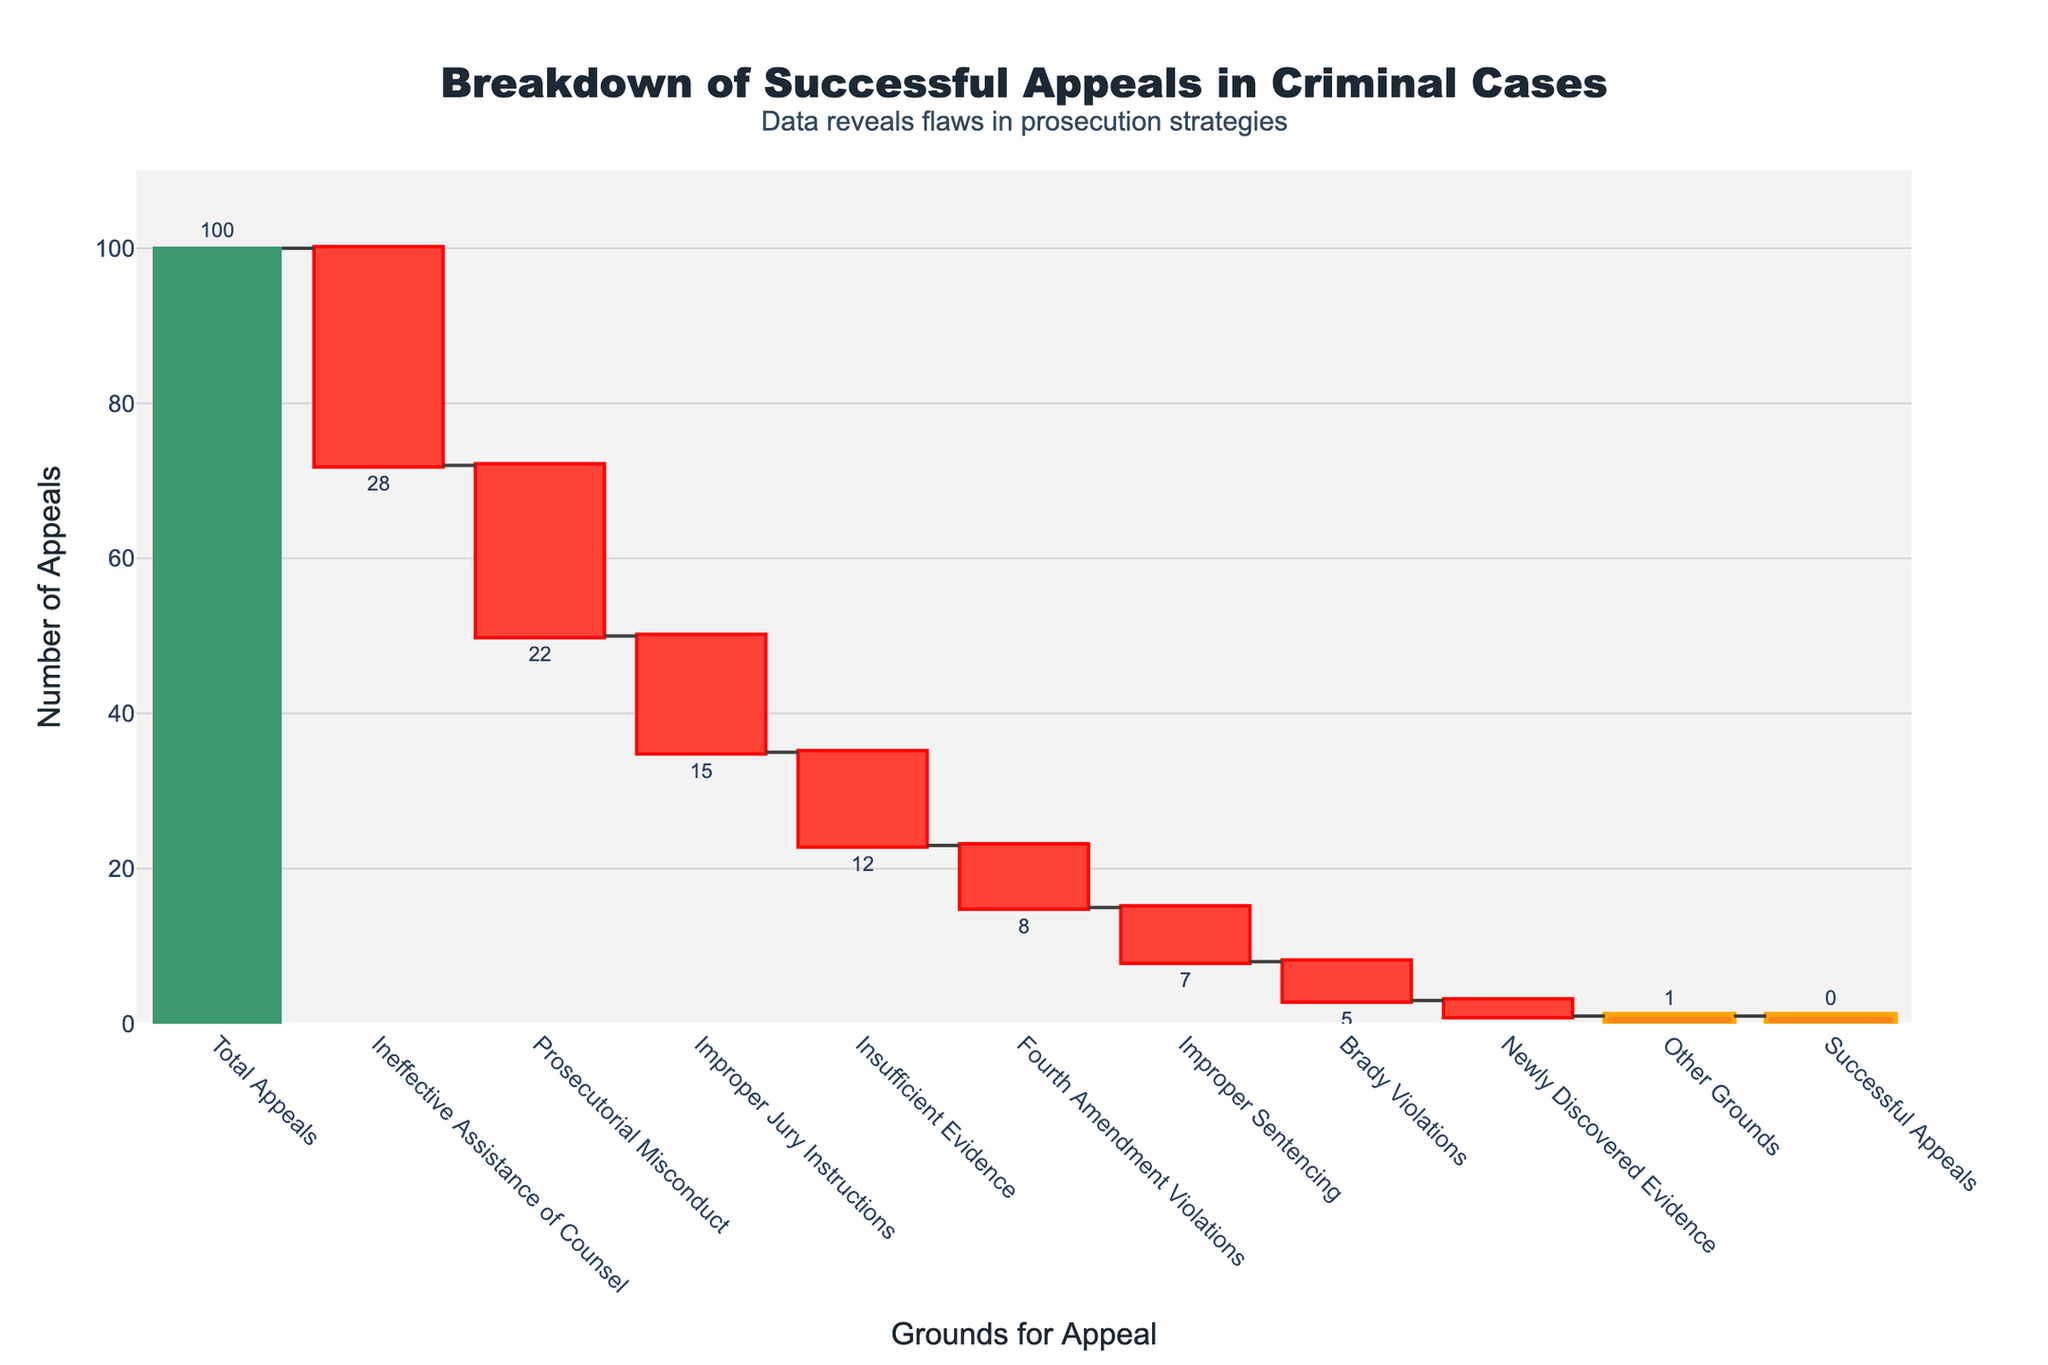What's the title of the figure? The title of the figure is usually located at the top and is written in larger text. In this case, it reads "Breakdown of Successful Appeals in Criminal Cases."
Answer: Breakdown of Successful Appeals in Criminal Cases Which grounds for appeal had the most significant reduction in the number of successful appeals? By looking at the figure, the largest drop is represented by the category with the longest negative bar. Here, "Ineffective Assistance of Counsel" shows the most significant reduction, with a value of -28.
Answer: Ineffective Assistance of Counsel What is the total number of unsuccessful appeals due to insufficient evidence? The figure shows "Insufficient Evidence" as a category with a negative value. The value associated with it is -12, indicating 12 unsuccessful appeals due to insufficient evidence.
Answer: 12 How many successful appeals were there after accounting for prosecutorial misconduct and improper jury instructions? First, we sum the appeals lost due to prosecutorial misconduct (-22) and improper jury instructions (-15). The total is -22 + -15 = -37. This value represents the combined reduction.
Answer: -37 Between Fourth Amendment Violations and Brady Violations, which one had fewer unsuccessful appeals? By comparing the values, Fourth Amendment Violations have a value of -8, and Brady Violations have a value of -5. Since -5 is closer to 0 than -8, Brady Violations had fewer unsuccessful appeals.
Answer: Brady Violations What's the total reduction in successful appeals from all specified categories combined (excluding "Total Appeals" and "Successful Appeals")? Sum all the negative values: -28 (Ineffective Assistance of Counsel) + -22 (Prosecutorial Misconduct) + -15 (Improper Jury Instructions) + -12 (Insufficient Evidence) + -8 (Fourth Amendment Violations) + -7 (Improper Sentencing) + -5 (Brady Violations) + -2 (Newly Discovered Evidence) + -1 (Other Grounds) = -100.
Answer: -100 How does the reduction due to improper sentencing compare to the reduction due to newly discovered evidence? Improper Sentencing has a value of -7, and Newly Discovered Evidence has a value of -2. Since -7 is a larger absolute number than -2, the reduction due to improper sentencing is greater.
Answer: Improper Sentencing Identify all the categories with a reduction of at least 10 appeals. Categories with a reduction of at least 10 are those where the negative values are -10 or lower. These are: Ineffective Assistance of Counsel (-28), Prosecutorial Misconduct (-22), Improper Jury Instructions (-15), and Insufficient Evidence (-12).
Answer: Ineffective Assistance of Counsel, Prosecutorial Misconduct, Improper Jury Instructions, Insufficient Evidence 